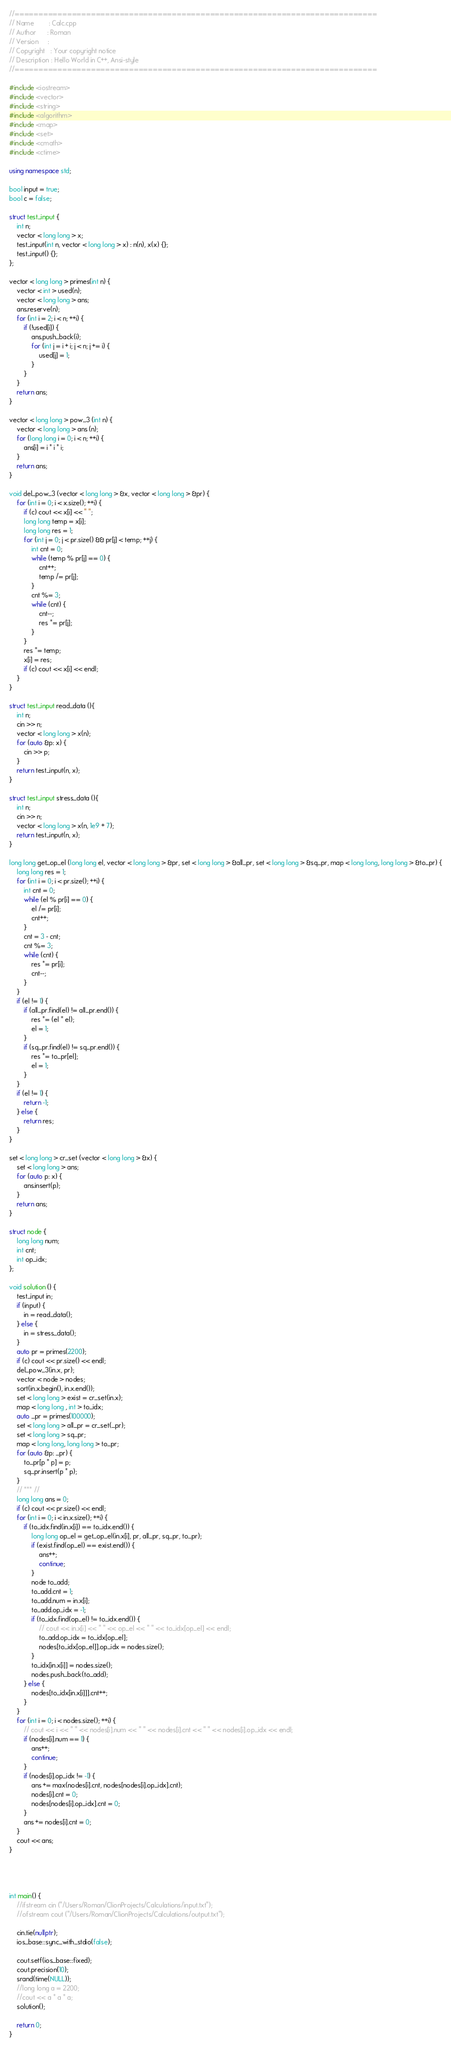<code> <loc_0><loc_0><loc_500><loc_500><_C++_>//============================================================================
// Name        : Calc.cpp
// Author      : Roman
// Version     :
// Copyright   : Your copyright notice
// Description : Hello World in C++, Ansi-style
//============================================================================

#include <iostream>
#include <vector>
#include <string>
#include <algorithm>
#include <map>
#include <set>
#include <cmath>
#include <ctime>

using namespace std;

bool input = true;
bool c = false;

struct test_input {
	int n;
	vector < long long > x;
	test_input(int n, vector < long long > x) : n(n), x(x) {};
	test_input() {};
};

vector < long long > primes(int n) {
	vector < int > used(n);
	vector < long long > ans;
	ans.reserve(n);
	for (int i = 2; i < n; ++i) {
		if (!used[i]) {
			ans.push_back(i);
			for (int j = i + i; j < n; j += i) {
				used[j] = 1;
			}
		}
	}
	return ans;
}

vector < long long > pow_3 (int n) {
	vector < long long > ans (n);
	for (long long i = 0; i < n; ++i) {
		ans[i] = i * i * i;
	}
	return ans;
}

void del_pow_3 (vector < long long > &x, vector < long long > &pr) {
	for (int i = 0; i < x.size(); ++i) {
		if (c) cout << x[i] << " ";
		long long temp = x[i];
		long long res = 1;
		for (int j = 0; j < pr.size() && pr[j] < temp; ++j) {
			int cnt = 0;
			while (temp % pr[j] == 0) {
				cnt++;
				temp /= pr[j];
			}
			cnt %= 3;
			while (cnt) {
				cnt--;
				res *= pr[j];
			}
		}
		res *= temp;
		x[i] = res;
		if (c) cout << x[i] << endl;
	}
}

struct test_input read_data (){
	int n;
	cin >> n;
	vector < long long > x(n);
	for (auto &p: x) {
		cin >> p;
	}
	return test_input(n, x);
}

struct test_input stress_data (){
	int n;
	cin >> n;
	vector < long long > x(n, 1e9 + 7);
	return test_input(n, x);
}

long long get_op_el (long long el, vector < long long > &pr, set < long long > &all_pr, set < long long > &sq_pr, map < long long, long long > &to_pr) {
	long long res = 1;
	for (int i = 0; i < pr.size(); ++i) {
		int cnt = 0;
		while (el % pr[i] == 0) {
			el /= pr[i];
			cnt++;
		}
		cnt = 3 - cnt;
		cnt %= 3;
		while (cnt) {
			res *= pr[i];
			cnt--;
		}
	}
	if (el != 1) {
		if (all_pr.find(el) != all_pr.end()) {
			res *= (el * el);
			el = 1;
		}
		if (sq_pr.find(el) != sq_pr.end()) {
			res *= to_pr[el];
			el = 1;
		}
	}
	if (el != 1) {
		return -1;
	} else {
		return res;
	}
}

set < long long > cr_set (vector < long long > &x) {
	set < long long > ans;
	for (auto p: x) {
		ans.insert(p);
	}
	return ans;
}

struct node {
	long long num;
	int cnt;
	int op_idx;
};

void solution () {
	test_input in;
	if (input) {
		in = read_data();
	} else {
		in = stress_data();
	}
	auto pr = primes(2200);
	if (c) cout << pr.size() << endl;
	del_pow_3(in.x, pr);
	vector < node > nodes;
	sort(in.x.begin(), in.x.end());
	set < long long > exist = cr_set(in.x);
	map < long long , int > to_idx;
	auto _pr = primes(100000);
	set < long long > all_pr = cr_set(_pr);
	set < long long > sq_pr;
	map < long long, long long > to_pr;
	for (auto &p: _pr) {
		to_pr[p * p] = p;
		sq_pr.insert(p * p);
	}
	// *** //
	long long ans = 0;
	if (c) cout << pr.size() << endl;
	for (int i = 0; i < in.x.size(); ++i) {
		if (to_idx.find(in.x[i]) == to_idx.end()) {
			long long op_el = get_op_el(in.x[i], pr, all_pr, sq_pr, to_pr);
			if (exist.find(op_el) == exist.end()) {
				ans++;
				continue;
			}
			node to_add;
			to_add.cnt = 1;
			to_add.num = in.x[i];
			to_add.op_idx = -1;
			if (to_idx.find(op_el) != to_idx.end()) {
				// cout << in.x[i] << " " << op_el << " " << to_idx[op_el] << endl;
				to_add.op_idx = to_idx[op_el];
				nodes[to_idx[op_el]].op_idx = nodes.size();
			}
			to_idx[in.x[i]] = nodes.size();
			nodes.push_back(to_add);
		} else {
			nodes[to_idx[in.x[i]]].cnt++;
		}
	}
	for (int i = 0; i < nodes.size(); ++i) {
		// cout << i << " " << nodes[i].num << " " << nodes[i].cnt << " " << nodes[i].op_idx << endl;
		if (nodes[i].num == 1) {
			ans++;
			continue;
		}
		if (nodes[i].op_idx != -1) {
			ans += max(nodes[i].cnt, nodes[nodes[i].op_idx].cnt);
			nodes[i].cnt = 0;
			nodes[nodes[i].op_idx].cnt = 0;
		}
		ans += nodes[i].cnt = 0;
	}
	cout << ans;
}




int main() {
	//ifstream cin ("/Users/Roman/ClionProjects/Calculations/input.txt");
	//ofstream cout ("/Users/Roman/ClionProjects/Calculations/output.txt");

	cin.tie(nullptr);
	ios_base::sync_with_stdio(false);

	cout.setf(ios_base::fixed);
	cout.precision(10);
	srand(time(NULL));
	//long long a = 2200;
	//cout << a * a * a;
	solution();

	return 0;
}

</code> 